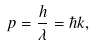Convert formula to latex. <formula><loc_0><loc_0><loc_500><loc_500>p = \frac { h } { \lambda } = \hbar { k } ,</formula> 